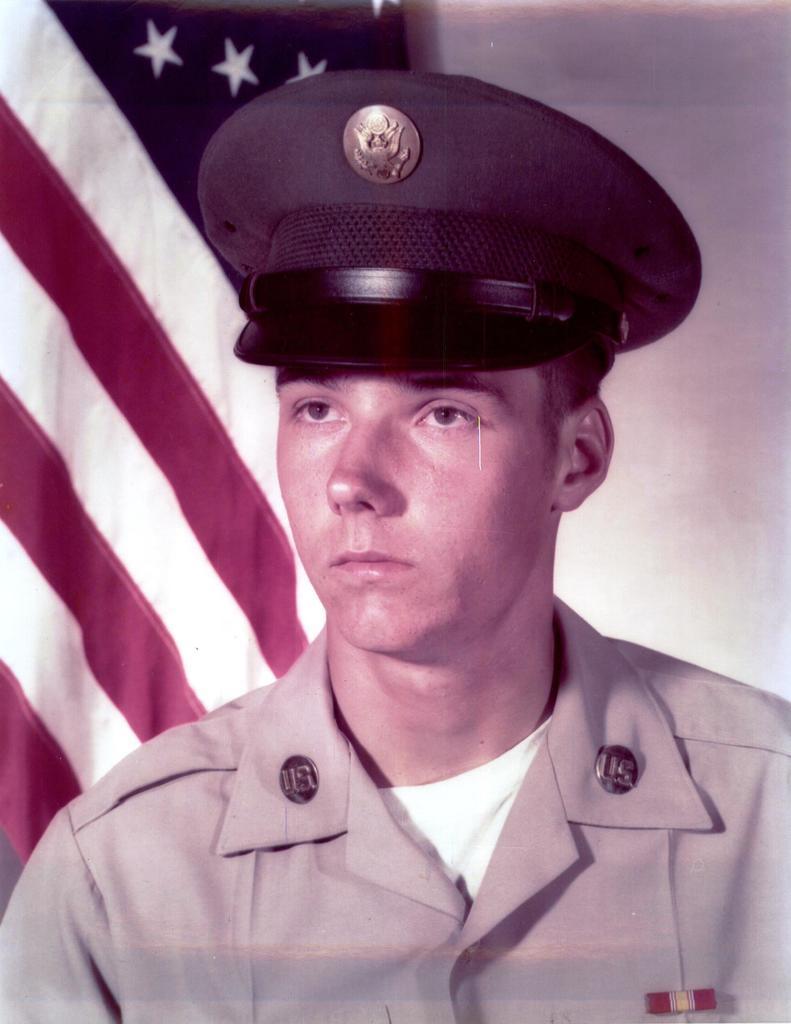Can you describe this image briefly? In this image we can see a person wearing the cap. In the background, we can see a flag and the wall. 